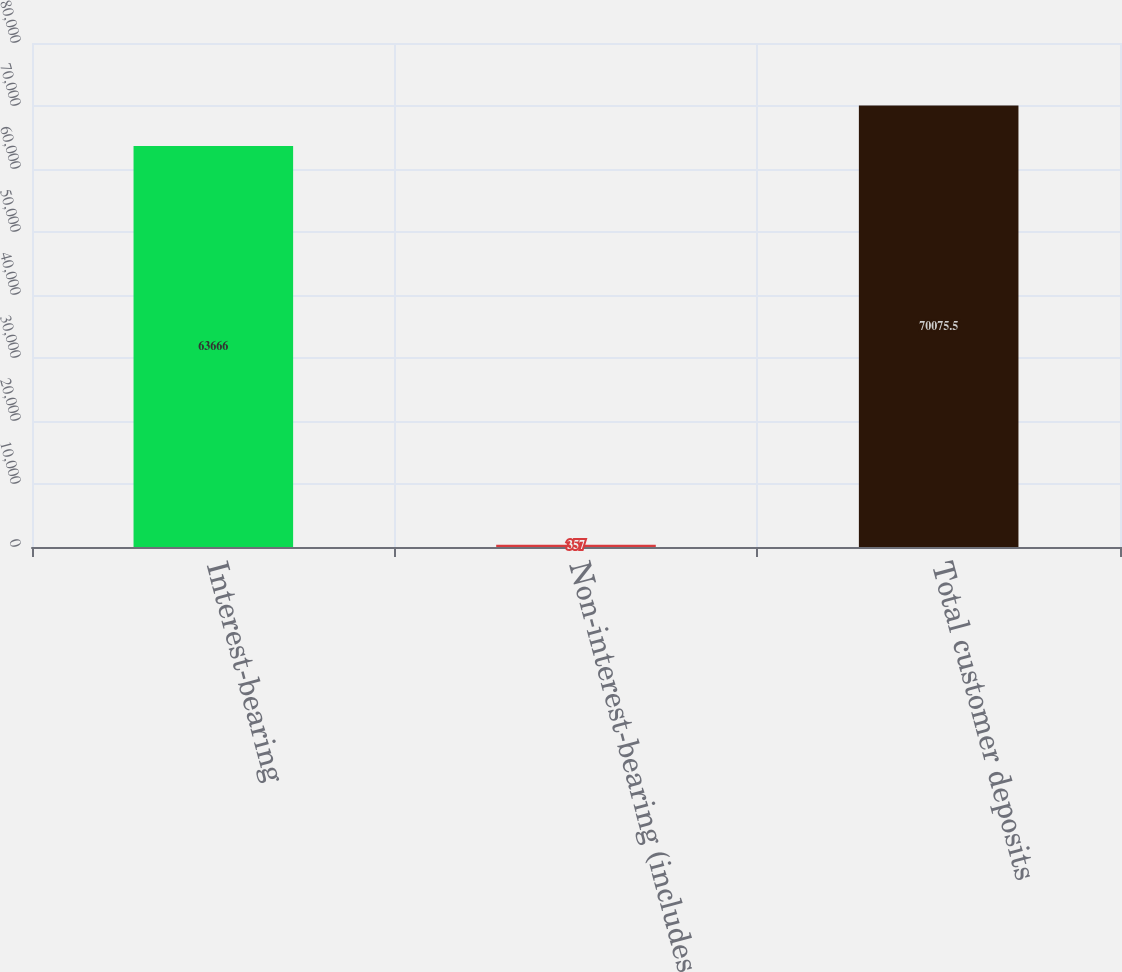<chart> <loc_0><loc_0><loc_500><loc_500><bar_chart><fcel>Interest-bearing<fcel>Non-interest-bearing (includes<fcel>Total customer deposits<nl><fcel>63666<fcel>357<fcel>70075.5<nl></chart> 